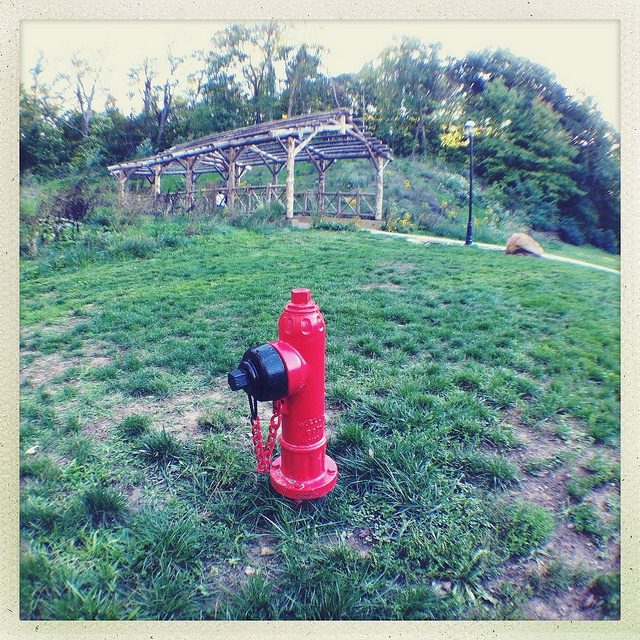Describe the objects in this image and their specific colors. I can see a fire hydrant in beige, brown, and navy tones in this image. 